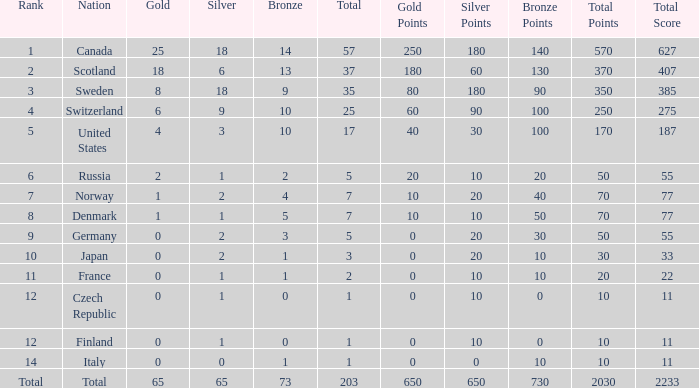What is the number of bronze medals when the total is greater than 1, more than 2 silver medals are won, and the rank is 2? 13.0. 